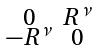<formula> <loc_0><loc_0><loc_500><loc_500>\begin{smallmatrix} 0 & R ^ { \nu } \\ - R ^ { \nu } & 0 \end{smallmatrix}</formula> 